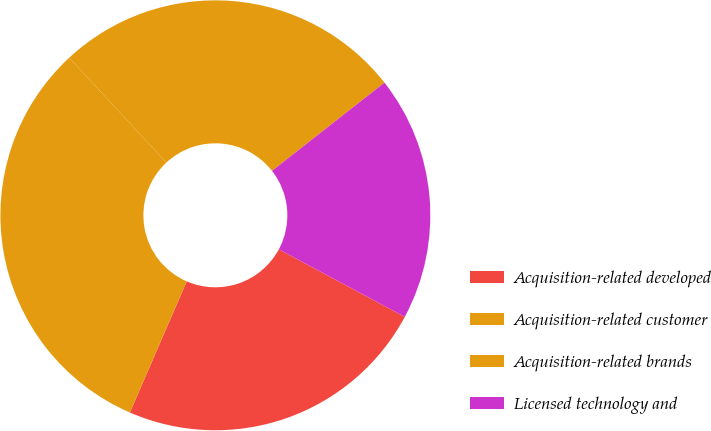Convert chart. <chart><loc_0><loc_0><loc_500><loc_500><pie_chart><fcel>Acquisition-related developed<fcel>Acquisition-related customer<fcel>Acquisition-related brands<fcel>Licensed technology and<nl><fcel>23.68%<fcel>31.58%<fcel>26.32%<fcel>18.42%<nl></chart> 